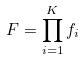<formula> <loc_0><loc_0><loc_500><loc_500>F = \prod _ { i = 1 } ^ { K } f _ { i }</formula> 